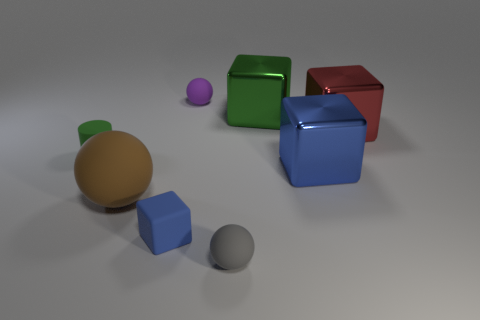Can you describe the lighting of the scene? Does it create any interesting effects on the surfaces of the objects? The lighting in the scene is soft and diffuse, coming from above. It creates subtle shadows behind the objects, enhancing their three-dimensional appearance. The shiny surfaces, particularly on the blue and red cubes, reflect the light in a way that highlights their glossy texture and sharp edges. 